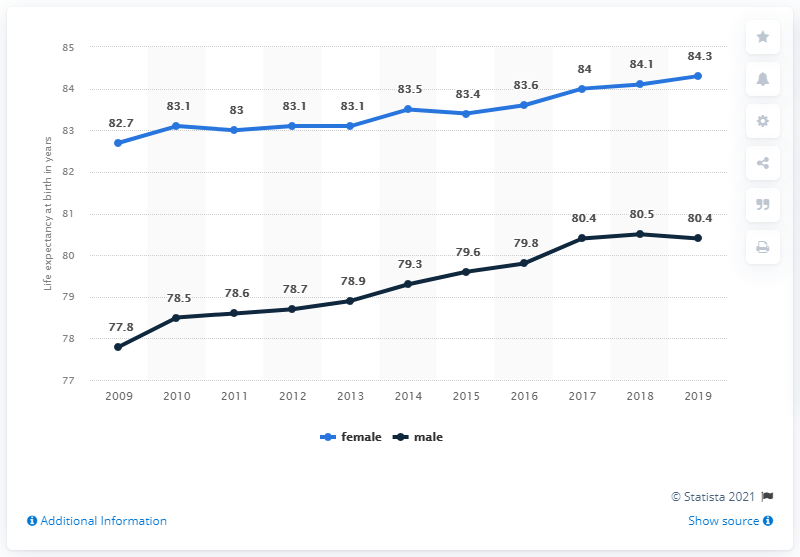Mention a couple of crucial points in this snapshot. The y-axis in the chart represents life expectancy at birth in years. I want to determine which line is higher than the other based on the gender of the corresponding data points, where female data points are on the left and male data points are on the right. 